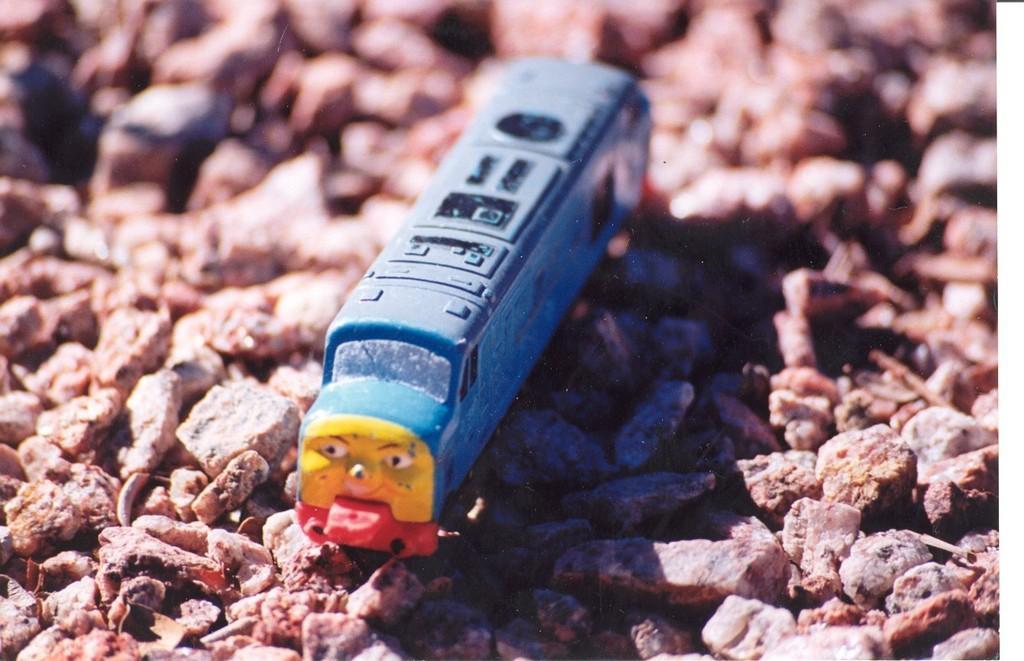Please provide a concise description of this image. There is a blue and yellow color toy car on the stones. 